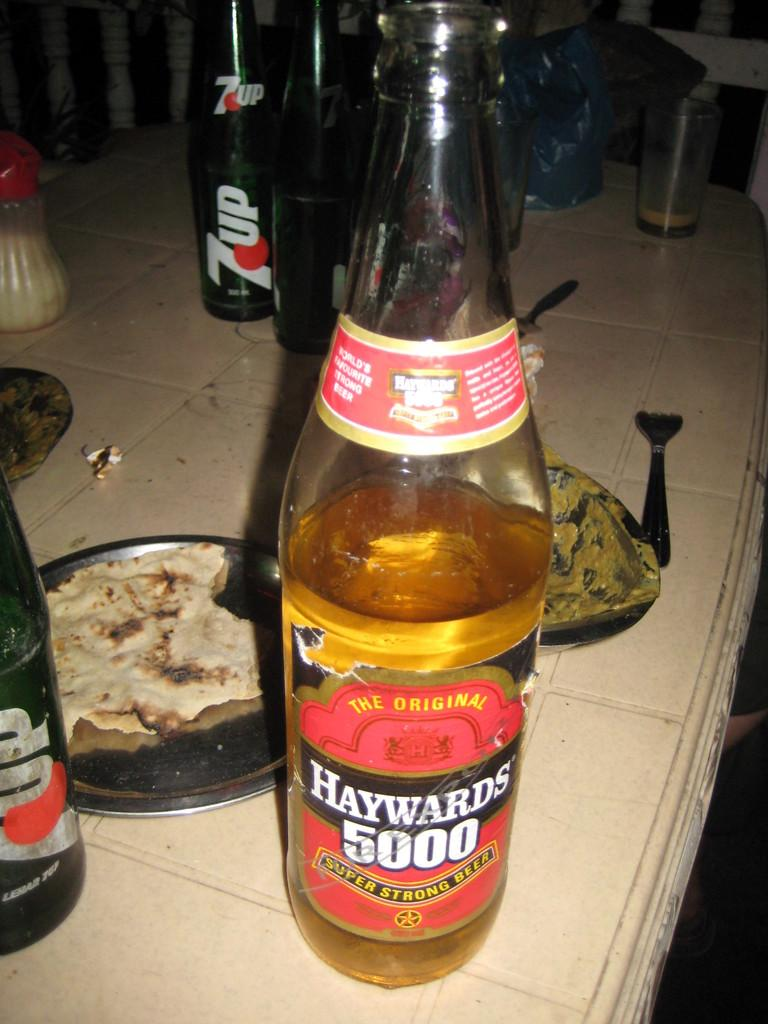<image>
Share a concise interpretation of the image provided. A bottle of Haywards beer is on the table with food and 7up. 